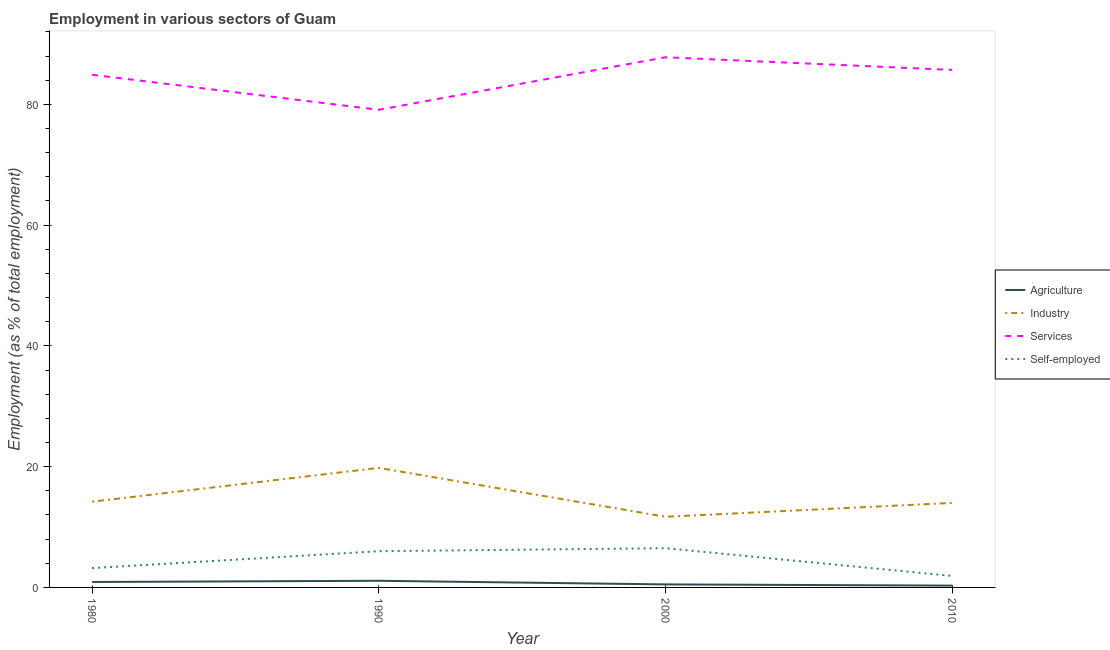How many different coloured lines are there?
Offer a terse response. 4. Does the line corresponding to percentage of workers in services intersect with the line corresponding to percentage of workers in industry?
Ensure brevity in your answer.  No. Is the number of lines equal to the number of legend labels?
Offer a very short reply. Yes. What is the percentage of workers in agriculture in 1990?
Provide a short and direct response. 1.1. Across all years, what is the maximum percentage of workers in industry?
Give a very brief answer. 19.8. Across all years, what is the minimum percentage of workers in services?
Keep it short and to the point. 79.1. In which year was the percentage of workers in services maximum?
Your answer should be very brief. 2000. What is the total percentage of workers in agriculture in the graph?
Offer a very short reply. 2.8. What is the difference between the percentage of workers in agriculture in 1980 and that in 1990?
Keep it short and to the point. -0.2. What is the difference between the percentage of workers in agriculture in 2000 and the percentage of workers in services in 1990?
Your answer should be very brief. -78.6. What is the average percentage of workers in services per year?
Your answer should be very brief. 84.37. In the year 1990, what is the difference between the percentage of workers in agriculture and percentage of workers in industry?
Provide a succinct answer. -18.7. What is the ratio of the percentage of workers in services in 1980 to that in 2010?
Offer a terse response. 0.99. Is the percentage of workers in services in 1980 less than that in 2010?
Your answer should be compact. Yes. What is the difference between the highest and the second highest percentage of workers in services?
Offer a terse response. 2.1. What is the difference between the highest and the lowest percentage of workers in services?
Your answer should be very brief. 8.7. In how many years, is the percentage of workers in industry greater than the average percentage of workers in industry taken over all years?
Ensure brevity in your answer.  1. Is it the case that in every year, the sum of the percentage of workers in services and percentage of workers in industry is greater than the sum of percentage of self employed workers and percentage of workers in agriculture?
Provide a short and direct response. Yes. Is it the case that in every year, the sum of the percentage of workers in agriculture and percentage of workers in industry is greater than the percentage of workers in services?
Your response must be concise. No. How many years are there in the graph?
Your response must be concise. 4. What is the difference between two consecutive major ticks on the Y-axis?
Your answer should be compact. 20. Does the graph contain grids?
Provide a short and direct response. No. Where does the legend appear in the graph?
Offer a terse response. Center right. How many legend labels are there?
Make the answer very short. 4. What is the title of the graph?
Ensure brevity in your answer.  Employment in various sectors of Guam. What is the label or title of the Y-axis?
Your answer should be very brief. Employment (as % of total employment). What is the Employment (as % of total employment) in Agriculture in 1980?
Ensure brevity in your answer.  0.9. What is the Employment (as % of total employment) in Industry in 1980?
Your answer should be compact. 14.2. What is the Employment (as % of total employment) in Services in 1980?
Provide a succinct answer. 84.9. What is the Employment (as % of total employment) in Self-employed in 1980?
Your response must be concise. 3.2. What is the Employment (as % of total employment) in Agriculture in 1990?
Your response must be concise. 1.1. What is the Employment (as % of total employment) of Industry in 1990?
Make the answer very short. 19.8. What is the Employment (as % of total employment) of Services in 1990?
Your response must be concise. 79.1. What is the Employment (as % of total employment) in Agriculture in 2000?
Make the answer very short. 0.5. What is the Employment (as % of total employment) of Industry in 2000?
Provide a succinct answer. 11.7. What is the Employment (as % of total employment) of Services in 2000?
Offer a very short reply. 87.8. What is the Employment (as % of total employment) of Agriculture in 2010?
Your response must be concise. 0.3. What is the Employment (as % of total employment) of Industry in 2010?
Provide a succinct answer. 14. What is the Employment (as % of total employment) in Services in 2010?
Your answer should be very brief. 85.7. What is the Employment (as % of total employment) of Self-employed in 2010?
Provide a succinct answer. 1.9. Across all years, what is the maximum Employment (as % of total employment) of Agriculture?
Offer a terse response. 1.1. Across all years, what is the maximum Employment (as % of total employment) in Industry?
Keep it short and to the point. 19.8. Across all years, what is the maximum Employment (as % of total employment) of Services?
Offer a terse response. 87.8. Across all years, what is the minimum Employment (as % of total employment) of Agriculture?
Your response must be concise. 0.3. Across all years, what is the minimum Employment (as % of total employment) in Industry?
Provide a succinct answer. 11.7. Across all years, what is the minimum Employment (as % of total employment) in Services?
Keep it short and to the point. 79.1. Across all years, what is the minimum Employment (as % of total employment) in Self-employed?
Make the answer very short. 1.9. What is the total Employment (as % of total employment) of Agriculture in the graph?
Keep it short and to the point. 2.8. What is the total Employment (as % of total employment) in Industry in the graph?
Make the answer very short. 59.7. What is the total Employment (as % of total employment) of Services in the graph?
Give a very brief answer. 337.5. What is the total Employment (as % of total employment) in Self-employed in the graph?
Keep it short and to the point. 17.6. What is the difference between the Employment (as % of total employment) of Self-employed in 1980 and that in 1990?
Keep it short and to the point. -2.8. What is the difference between the Employment (as % of total employment) of Agriculture in 1980 and that in 2000?
Provide a short and direct response. 0.4. What is the difference between the Employment (as % of total employment) of Industry in 1980 and that in 2000?
Make the answer very short. 2.5. What is the difference between the Employment (as % of total employment) in Industry in 1980 and that in 2010?
Your response must be concise. 0.2. What is the difference between the Employment (as % of total employment) of Services in 1980 and that in 2010?
Your answer should be very brief. -0.8. What is the difference between the Employment (as % of total employment) in Self-employed in 1980 and that in 2010?
Ensure brevity in your answer.  1.3. What is the difference between the Employment (as % of total employment) in Industry in 1990 and that in 2000?
Ensure brevity in your answer.  8.1. What is the difference between the Employment (as % of total employment) of Self-employed in 1990 and that in 2000?
Provide a short and direct response. -0.5. What is the difference between the Employment (as % of total employment) in Agriculture in 1990 and that in 2010?
Your answer should be very brief. 0.8. What is the difference between the Employment (as % of total employment) in Services in 1990 and that in 2010?
Offer a very short reply. -6.6. What is the difference between the Employment (as % of total employment) of Self-employed in 1990 and that in 2010?
Offer a terse response. 4.1. What is the difference between the Employment (as % of total employment) of Agriculture in 2000 and that in 2010?
Your response must be concise. 0.2. What is the difference between the Employment (as % of total employment) of Agriculture in 1980 and the Employment (as % of total employment) of Industry in 1990?
Your answer should be compact. -18.9. What is the difference between the Employment (as % of total employment) of Agriculture in 1980 and the Employment (as % of total employment) of Services in 1990?
Ensure brevity in your answer.  -78.2. What is the difference between the Employment (as % of total employment) in Agriculture in 1980 and the Employment (as % of total employment) in Self-employed in 1990?
Provide a short and direct response. -5.1. What is the difference between the Employment (as % of total employment) in Industry in 1980 and the Employment (as % of total employment) in Services in 1990?
Provide a short and direct response. -64.9. What is the difference between the Employment (as % of total employment) in Industry in 1980 and the Employment (as % of total employment) in Self-employed in 1990?
Offer a terse response. 8.2. What is the difference between the Employment (as % of total employment) in Services in 1980 and the Employment (as % of total employment) in Self-employed in 1990?
Provide a succinct answer. 78.9. What is the difference between the Employment (as % of total employment) in Agriculture in 1980 and the Employment (as % of total employment) in Industry in 2000?
Make the answer very short. -10.8. What is the difference between the Employment (as % of total employment) in Agriculture in 1980 and the Employment (as % of total employment) in Services in 2000?
Provide a short and direct response. -86.9. What is the difference between the Employment (as % of total employment) in Industry in 1980 and the Employment (as % of total employment) in Services in 2000?
Ensure brevity in your answer.  -73.6. What is the difference between the Employment (as % of total employment) of Services in 1980 and the Employment (as % of total employment) of Self-employed in 2000?
Provide a short and direct response. 78.4. What is the difference between the Employment (as % of total employment) in Agriculture in 1980 and the Employment (as % of total employment) in Services in 2010?
Provide a succinct answer. -84.8. What is the difference between the Employment (as % of total employment) in Agriculture in 1980 and the Employment (as % of total employment) in Self-employed in 2010?
Provide a short and direct response. -1. What is the difference between the Employment (as % of total employment) in Industry in 1980 and the Employment (as % of total employment) in Services in 2010?
Provide a short and direct response. -71.5. What is the difference between the Employment (as % of total employment) of Industry in 1980 and the Employment (as % of total employment) of Self-employed in 2010?
Your response must be concise. 12.3. What is the difference between the Employment (as % of total employment) of Services in 1980 and the Employment (as % of total employment) of Self-employed in 2010?
Your answer should be compact. 83. What is the difference between the Employment (as % of total employment) of Agriculture in 1990 and the Employment (as % of total employment) of Industry in 2000?
Offer a terse response. -10.6. What is the difference between the Employment (as % of total employment) of Agriculture in 1990 and the Employment (as % of total employment) of Services in 2000?
Your answer should be compact. -86.7. What is the difference between the Employment (as % of total employment) of Agriculture in 1990 and the Employment (as % of total employment) of Self-employed in 2000?
Offer a very short reply. -5.4. What is the difference between the Employment (as % of total employment) in Industry in 1990 and the Employment (as % of total employment) in Services in 2000?
Offer a terse response. -68. What is the difference between the Employment (as % of total employment) of Industry in 1990 and the Employment (as % of total employment) of Self-employed in 2000?
Make the answer very short. 13.3. What is the difference between the Employment (as % of total employment) in Services in 1990 and the Employment (as % of total employment) in Self-employed in 2000?
Offer a very short reply. 72.6. What is the difference between the Employment (as % of total employment) of Agriculture in 1990 and the Employment (as % of total employment) of Industry in 2010?
Give a very brief answer. -12.9. What is the difference between the Employment (as % of total employment) of Agriculture in 1990 and the Employment (as % of total employment) of Services in 2010?
Your answer should be very brief. -84.6. What is the difference between the Employment (as % of total employment) of Industry in 1990 and the Employment (as % of total employment) of Services in 2010?
Your answer should be very brief. -65.9. What is the difference between the Employment (as % of total employment) of Industry in 1990 and the Employment (as % of total employment) of Self-employed in 2010?
Your response must be concise. 17.9. What is the difference between the Employment (as % of total employment) of Services in 1990 and the Employment (as % of total employment) of Self-employed in 2010?
Provide a short and direct response. 77.2. What is the difference between the Employment (as % of total employment) of Agriculture in 2000 and the Employment (as % of total employment) of Industry in 2010?
Offer a terse response. -13.5. What is the difference between the Employment (as % of total employment) of Agriculture in 2000 and the Employment (as % of total employment) of Services in 2010?
Ensure brevity in your answer.  -85.2. What is the difference between the Employment (as % of total employment) in Agriculture in 2000 and the Employment (as % of total employment) in Self-employed in 2010?
Provide a succinct answer. -1.4. What is the difference between the Employment (as % of total employment) of Industry in 2000 and the Employment (as % of total employment) of Services in 2010?
Keep it short and to the point. -74. What is the difference between the Employment (as % of total employment) of Services in 2000 and the Employment (as % of total employment) of Self-employed in 2010?
Provide a short and direct response. 85.9. What is the average Employment (as % of total employment) in Agriculture per year?
Ensure brevity in your answer.  0.7. What is the average Employment (as % of total employment) in Industry per year?
Offer a very short reply. 14.93. What is the average Employment (as % of total employment) in Services per year?
Offer a very short reply. 84.38. What is the average Employment (as % of total employment) in Self-employed per year?
Your answer should be very brief. 4.4. In the year 1980, what is the difference between the Employment (as % of total employment) of Agriculture and Employment (as % of total employment) of Services?
Give a very brief answer. -84. In the year 1980, what is the difference between the Employment (as % of total employment) of Industry and Employment (as % of total employment) of Services?
Offer a terse response. -70.7. In the year 1980, what is the difference between the Employment (as % of total employment) in Industry and Employment (as % of total employment) in Self-employed?
Make the answer very short. 11. In the year 1980, what is the difference between the Employment (as % of total employment) of Services and Employment (as % of total employment) of Self-employed?
Keep it short and to the point. 81.7. In the year 1990, what is the difference between the Employment (as % of total employment) of Agriculture and Employment (as % of total employment) of Industry?
Give a very brief answer. -18.7. In the year 1990, what is the difference between the Employment (as % of total employment) of Agriculture and Employment (as % of total employment) of Services?
Provide a short and direct response. -78. In the year 1990, what is the difference between the Employment (as % of total employment) in Agriculture and Employment (as % of total employment) in Self-employed?
Keep it short and to the point. -4.9. In the year 1990, what is the difference between the Employment (as % of total employment) of Industry and Employment (as % of total employment) of Services?
Keep it short and to the point. -59.3. In the year 1990, what is the difference between the Employment (as % of total employment) in Services and Employment (as % of total employment) in Self-employed?
Give a very brief answer. 73.1. In the year 2000, what is the difference between the Employment (as % of total employment) in Agriculture and Employment (as % of total employment) in Services?
Provide a short and direct response. -87.3. In the year 2000, what is the difference between the Employment (as % of total employment) of Agriculture and Employment (as % of total employment) of Self-employed?
Your answer should be compact. -6. In the year 2000, what is the difference between the Employment (as % of total employment) of Industry and Employment (as % of total employment) of Services?
Make the answer very short. -76.1. In the year 2000, what is the difference between the Employment (as % of total employment) in Services and Employment (as % of total employment) in Self-employed?
Make the answer very short. 81.3. In the year 2010, what is the difference between the Employment (as % of total employment) of Agriculture and Employment (as % of total employment) of Industry?
Your answer should be compact. -13.7. In the year 2010, what is the difference between the Employment (as % of total employment) in Agriculture and Employment (as % of total employment) in Services?
Your answer should be compact. -85.4. In the year 2010, what is the difference between the Employment (as % of total employment) of Agriculture and Employment (as % of total employment) of Self-employed?
Give a very brief answer. -1.6. In the year 2010, what is the difference between the Employment (as % of total employment) of Industry and Employment (as % of total employment) of Services?
Offer a terse response. -71.7. In the year 2010, what is the difference between the Employment (as % of total employment) in Services and Employment (as % of total employment) in Self-employed?
Your response must be concise. 83.8. What is the ratio of the Employment (as % of total employment) in Agriculture in 1980 to that in 1990?
Offer a very short reply. 0.82. What is the ratio of the Employment (as % of total employment) in Industry in 1980 to that in 1990?
Provide a succinct answer. 0.72. What is the ratio of the Employment (as % of total employment) of Services in 1980 to that in 1990?
Offer a very short reply. 1.07. What is the ratio of the Employment (as % of total employment) in Self-employed in 1980 to that in 1990?
Give a very brief answer. 0.53. What is the ratio of the Employment (as % of total employment) in Agriculture in 1980 to that in 2000?
Keep it short and to the point. 1.8. What is the ratio of the Employment (as % of total employment) of Industry in 1980 to that in 2000?
Your answer should be very brief. 1.21. What is the ratio of the Employment (as % of total employment) of Services in 1980 to that in 2000?
Keep it short and to the point. 0.97. What is the ratio of the Employment (as % of total employment) in Self-employed in 1980 to that in 2000?
Offer a very short reply. 0.49. What is the ratio of the Employment (as % of total employment) in Industry in 1980 to that in 2010?
Provide a short and direct response. 1.01. What is the ratio of the Employment (as % of total employment) in Services in 1980 to that in 2010?
Provide a short and direct response. 0.99. What is the ratio of the Employment (as % of total employment) in Self-employed in 1980 to that in 2010?
Make the answer very short. 1.68. What is the ratio of the Employment (as % of total employment) in Industry in 1990 to that in 2000?
Make the answer very short. 1.69. What is the ratio of the Employment (as % of total employment) of Services in 1990 to that in 2000?
Provide a succinct answer. 0.9. What is the ratio of the Employment (as % of total employment) of Self-employed in 1990 to that in 2000?
Ensure brevity in your answer.  0.92. What is the ratio of the Employment (as % of total employment) in Agriculture in 1990 to that in 2010?
Keep it short and to the point. 3.67. What is the ratio of the Employment (as % of total employment) in Industry in 1990 to that in 2010?
Make the answer very short. 1.41. What is the ratio of the Employment (as % of total employment) of Services in 1990 to that in 2010?
Keep it short and to the point. 0.92. What is the ratio of the Employment (as % of total employment) in Self-employed in 1990 to that in 2010?
Your answer should be compact. 3.16. What is the ratio of the Employment (as % of total employment) in Industry in 2000 to that in 2010?
Give a very brief answer. 0.84. What is the ratio of the Employment (as % of total employment) of Services in 2000 to that in 2010?
Make the answer very short. 1.02. What is the ratio of the Employment (as % of total employment) of Self-employed in 2000 to that in 2010?
Keep it short and to the point. 3.42. What is the difference between the highest and the second highest Employment (as % of total employment) in Agriculture?
Ensure brevity in your answer.  0.2. What is the difference between the highest and the second highest Employment (as % of total employment) of Industry?
Your response must be concise. 5.6. What is the difference between the highest and the second highest Employment (as % of total employment) of Services?
Your answer should be compact. 2.1. What is the difference between the highest and the second highest Employment (as % of total employment) of Self-employed?
Offer a very short reply. 0.5. What is the difference between the highest and the lowest Employment (as % of total employment) in Services?
Keep it short and to the point. 8.7. What is the difference between the highest and the lowest Employment (as % of total employment) of Self-employed?
Offer a very short reply. 4.6. 